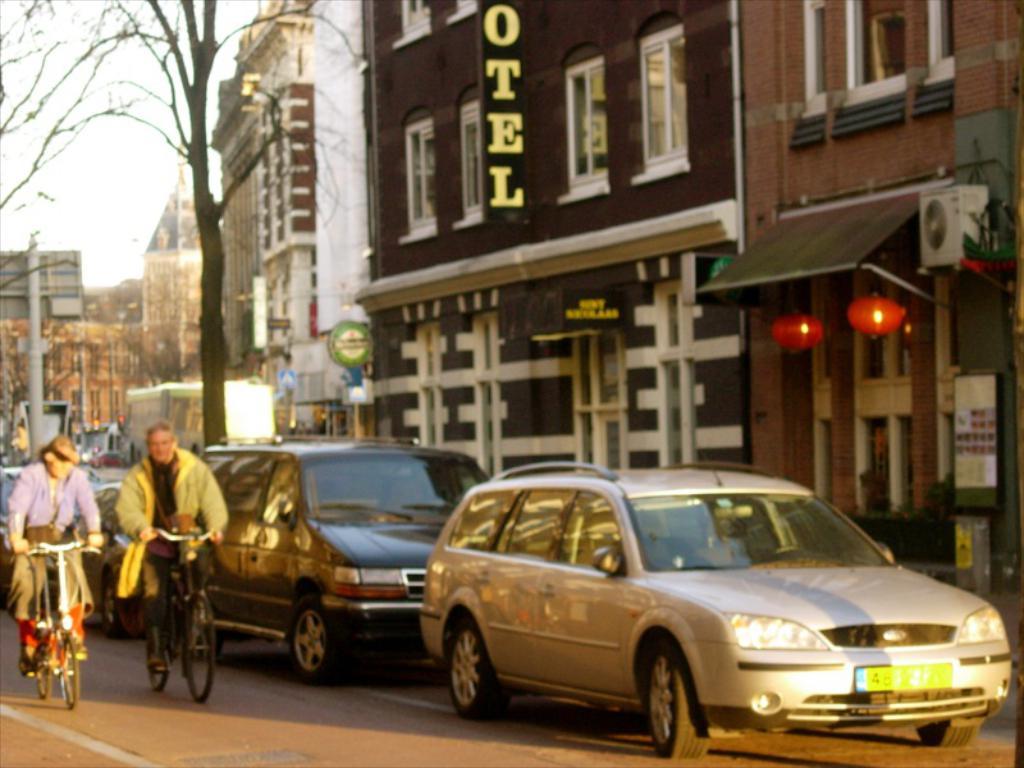What establishment is the one shown in the picture?
Offer a very short reply. Hotel. 